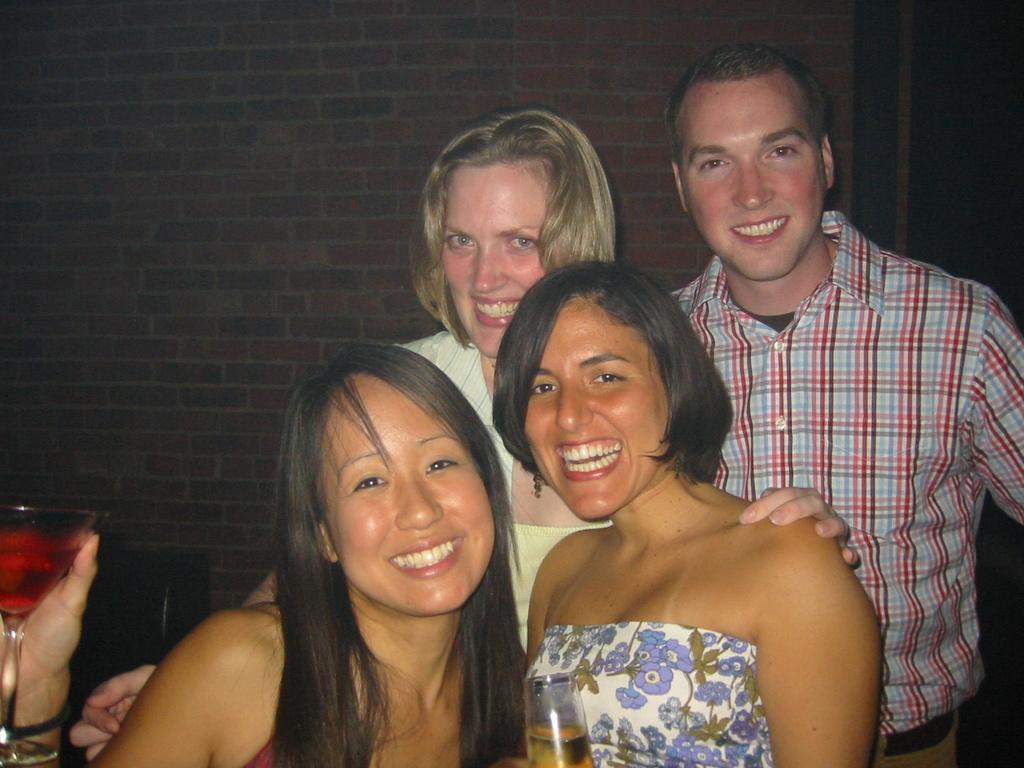Describe this image in one or two sentences. There are three women and one man standing together and giving smile. In which two women are holding glasses with alcohol. 